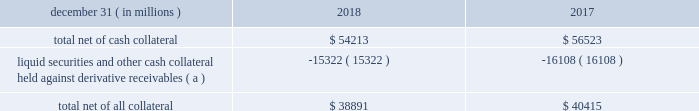Jpmorgan chase & co./2018 form 10-k 117 lending-related commitments the firm uses lending-related financial instruments , such as commitments ( including revolving credit facilities ) and guarantees , to address the financing needs of its clients .
The contractual amounts of these financial instruments represent the maximum possible credit risk should the clients draw down on these commitments or the firm fulfill its obligations under these guarantees , and the clients subsequently fail to perform according to the terms of these contracts .
Most of these commitments and guarantees are refinanced , extended , cancelled , or expire without being drawn upon or a default occurring .
In the firm 2019s view , the total contractual amount of these wholesale lending-related commitments is not representative of the firm 2019s expected future credit exposure or funding requirements .
For further information on wholesale lending-related commitments , refer to note 27 .
Clearing services the firm provides clearing services for clients entering into certain securities and derivative contracts .
Through the provision of these services the firm is exposed to the risk of non-performance by its clients and may be required to share in losses incurred by ccps .
Where possible , the firm seeks to mitigate its credit risk to its clients through the collection of adequate margin at inception and throughout the life of the transactions and can also cease provision of clearing services if clients do not adhere to their obligations under the clearing agreement .
For further discussion of clearing services , refer to note 27 .
Derivative contracts derivatives enable clients and counterparties to manage risks including credit risk and risks arising from fluctuations in interest rates , foreign exchange , equities , and commodities .
The firm makes markets in derivatives in order to meet these needs and uses derivatives to manage certain risks associated with net open risk positions from its market-making activities , including the counterparty credit risk arising from derivative receivables .
The firm also uses derivative instruments to manage its own credit and other market risk exposure .
The nature of the counterparty and the settlement mechanism of the derivative affect the credit risk to which the firm is exposed .
For otc derivatives the firm is exposed to the credit risk of the derivative counterparty .
For exchange-traded derivatives ( 201cetd 201d ) , such as futures and options , and 201ccleared 201d over-the-counter ( 201cotc-cleared 201d ) derivatives , the firm is generally exposed to the credit risk of the relevant ccp .
Where possible , the firm seeks to mitigate its credit risk exposures arising from derivative contracts through the use of legally enforceable master netting arrangements and collateral agreements .
For a further discussion of derivative contracts , counterparties and settlement types , refer to note 5 .
The table summarizes the net derivative receivables for the periods presented .
Derivative receivables .
( a ) includes collateral related to derivative instruments where appropriate legal opinions have not been either sought or obtained with respect to master netting agreements .
The fair value of derivative receivables reported on the consolidated balance sheets were $ 54.2 billion and $ 56.5 billion at december 31 , 2018 and 2017 , respectively .
Derivative receivables represent the fair value of the derivative contracts after giving effect to legally enforceable master netting agreements and cash collateral held by the firm .
However , in management 2019s view , the appropriate measure of current credit risk should also take into consideration additional liquid securities ( primarily u.s .
Government and agency securities and other group of seven nations ( 201cg7 201d ) government securities ) and other cash collateral held by the firm aggregating $ 15.3 billion and $ 16.1 billion at december 31 , 2018 and 2017 , respectively , that may be used as security when the fair value of the client 2019s exposure is in the firm 2019s favor .
In addition to the collateral described in the preceding paragraph , the firm also holds additional collateral ( primarily cash , g7 government securities , other liquid government-agency and guaranteed securities , and corporate debt and equity securities ) delivered by clients at the initiation of transactions , as well as collateral related to contracts that have a non-daily call frequency and collateral that the firm has agreed to return but has not yet settled as of the reporting date .
Although this collateral does not reduce the balances and is not included in the table above , it is available as security against potential exposure that could arise should the fair value of the client 2019s derivative contracts move in the firm 2019s favor .
The derivative receivables fair value , net of all collateral , also does not include other credit enhancements , such as letters of credit .
For additional information on the firm 2019s use of collateral agreements , refer to note 5 .
While useful as a current view of credit exposure , the net fair value of the derivative receivables does not capture the potential future variability of that credit exposure .
To capture the potential future variability of credit exposure , the firm calculates , on a client-by-client basis , three measures of potential derivatives-related credit loss : peak , derivative risk equivalent ( 201cdre 201d ) , and average exposure ( 201cavg 201d ) .
These measures all incorporate netting and collateral benefits , where applicable .
Peak represents a conservative measure of potential exposure to a counterparty calculated in a manner that is broadly equivalent to a 97.5% ( 97.5 % ) confidence level over the life of the transaction .
Peak is the primary measure used by the firm for setting of credit limits for derivative contracts , senior management reporting and derivatives exposure management .
Dre exposure is a measure that expresses the risk of derivative exposure on a basis intended to be .
What was the ratio of the fair value of derivative receivables reported on the consolidated balance sheets at december 31 , 2018 and 2017 .? 
Computations: (54.2 / 56.5)
Answer: 0.95929. 